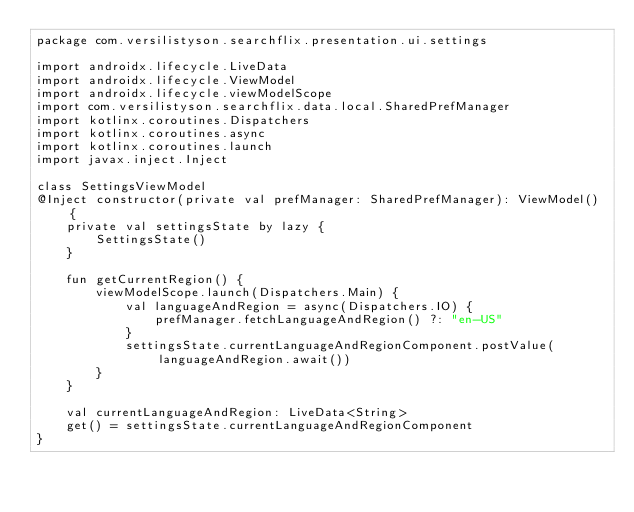<code> <loc_0><loc_0><loc_500><loc_500><_Kotlin_>package com.versilistyson.searchflix.presentation.ui.settings

import androidx.lifecycle.LiveData
import androidx.lifecycle.ViewModel
import androidx.lifecycle.viewModelScope
import com.versilistyson.searchflix.data.local.SharedPrefManager
import kotlinx.coroutines.Dispatchers
import kotlinx.coroutines.async
import kotlinx.coroutines.launch
import javax.inject.Inject

class SettingsViewModel
@Inject constructor(private val prefManager: SharedPrefManager): ViewModel() {
    private val settingsState by lazy {
        SettingsState()
    }

    fun getCurrentRegion() {
        viewModelScope.launch(Dispatchers.Main) {
            val languageAndRegion = async(Dispatchers.IO) {
                prefManager.fetchLanguageAndRegion() ?: "en-US"
            }
            settingsState.currentLanguageAndRegionComponent.postValue(languageAndRegion.await())
        }
    }

    val currentLanguageAndRegion: LiveData<String>
    get() = settingsState.currentLanguageAndRegionComponent
}</code> 